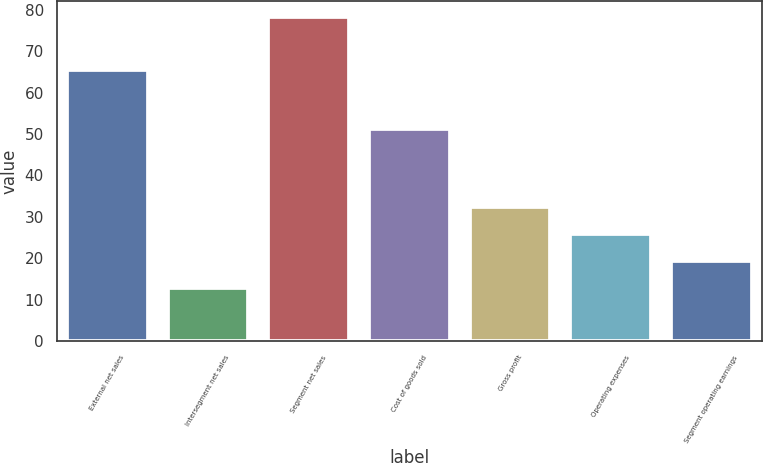Convert chart. <chart><loc_0><loc_0><loc_500><loc_500><bar_chart><fcel>External net sales<fcel>Intersegment net sales<fcel>Segment net sales<fcel>Cost of goods sold<fcel>Gross profit<fcel>Operating expenses<fcel>Segment operating earnings<nl><fcel>65.5<fcel>12.8<fcel>78.3<fcel>51.3<fcel>32.45<fcel>25.9<fcel>19.35<nl></chart> 